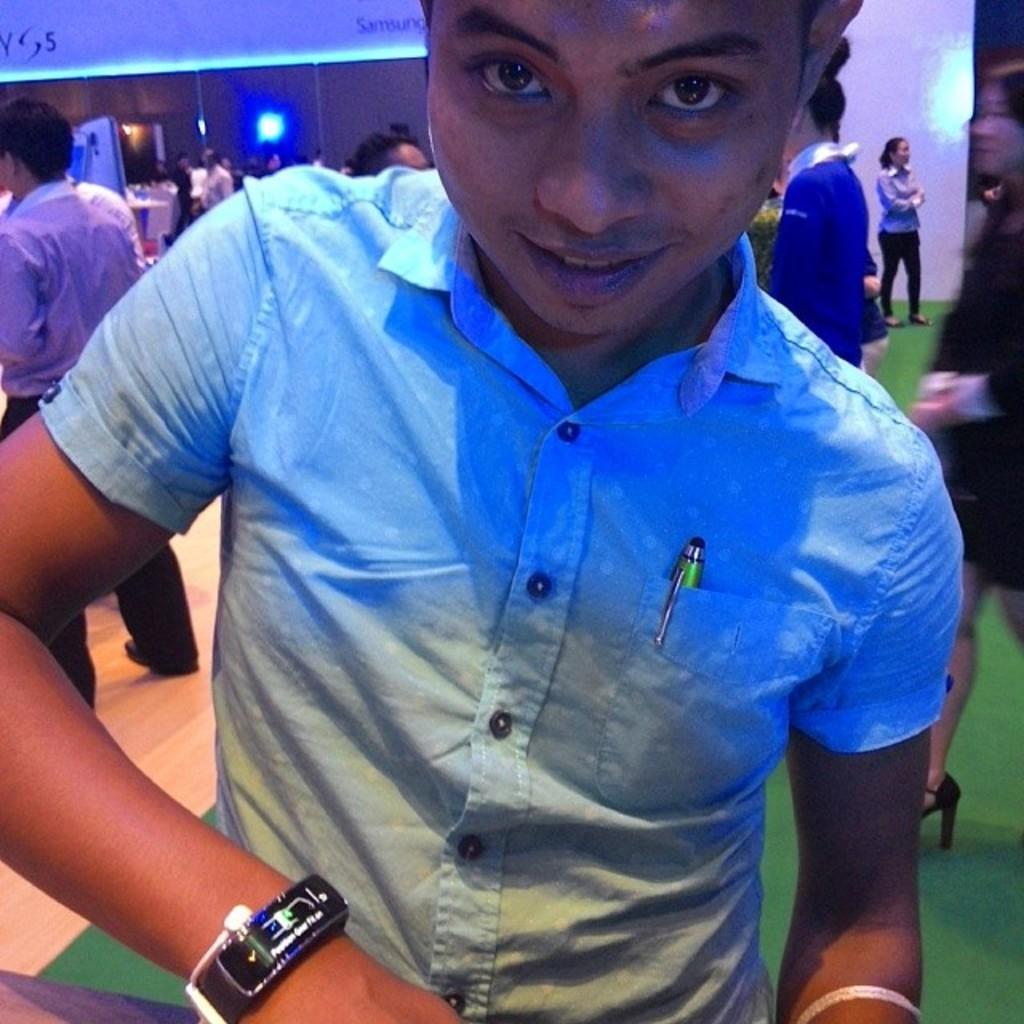Could you give a brief overview of what you see in this image? In this image I can see a person standing wearing blue color shirt, background I can see few other persons standing, wall in brown color and I can see few lights. 